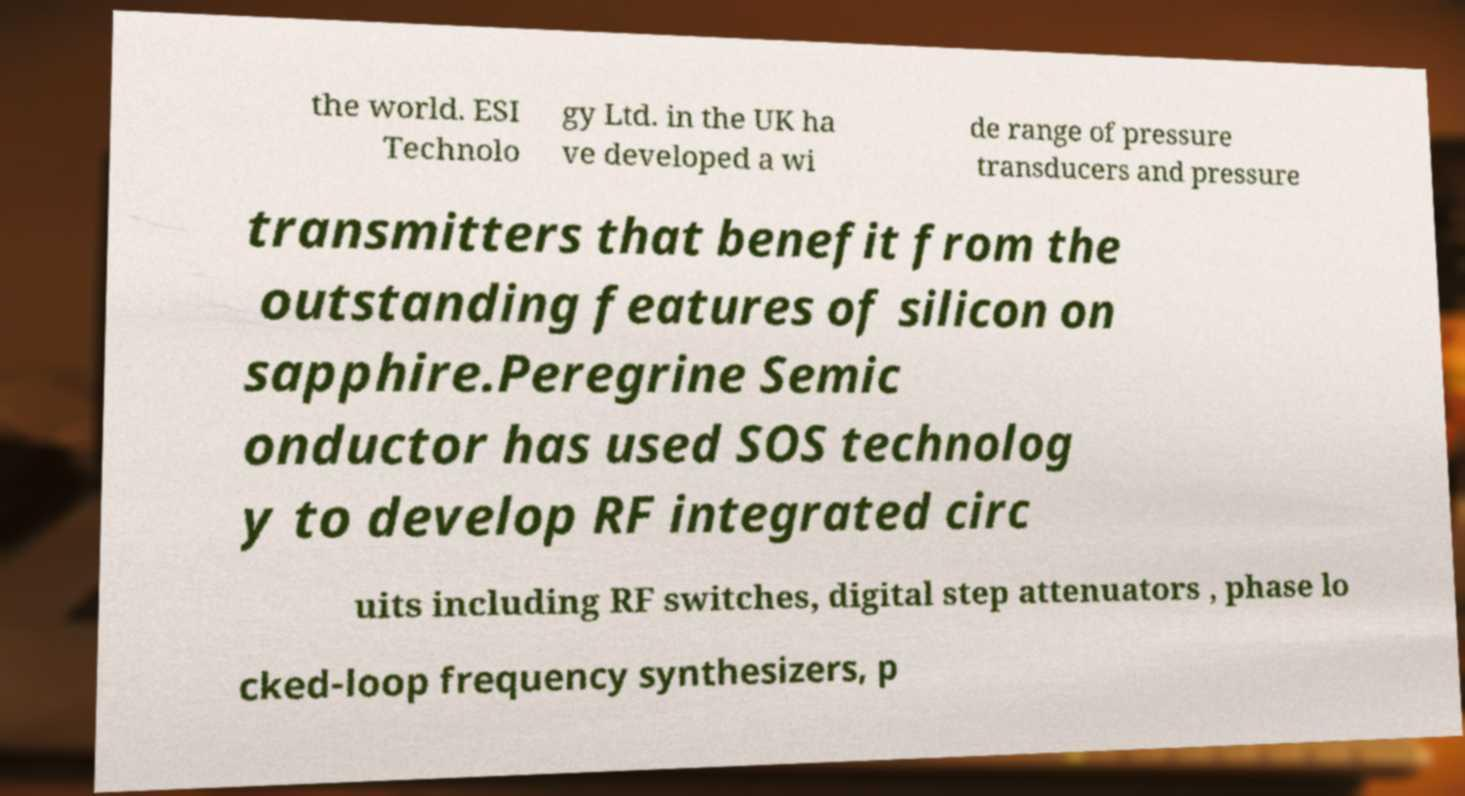Please read and relay the text visible in this image. What does it say? the world. ESI Technolo gy Ltd. in the UK ha ve developed a wi de range of pressure transducers and pressure transmitters that benefit from the outstanding features of silicon on sapphire.Peregrine Semic onductor has used SOS technolog y to develop RF integrated circ uits including RF switches, digital step attenuators , phase lo cked-loop frequency synthesizers, p 